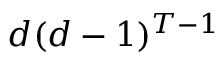<formula> <loc_0><loc_0><loc_500><loc_500>d ( d - 1 ) ^ { T - 1 }</formula> 